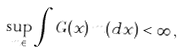<formula> <loc_0><loc_0><loc_500><loc_500>\sup _ { m \in } \int G ( x ) \, m ( d x ) < \infty \, ,</formula> 